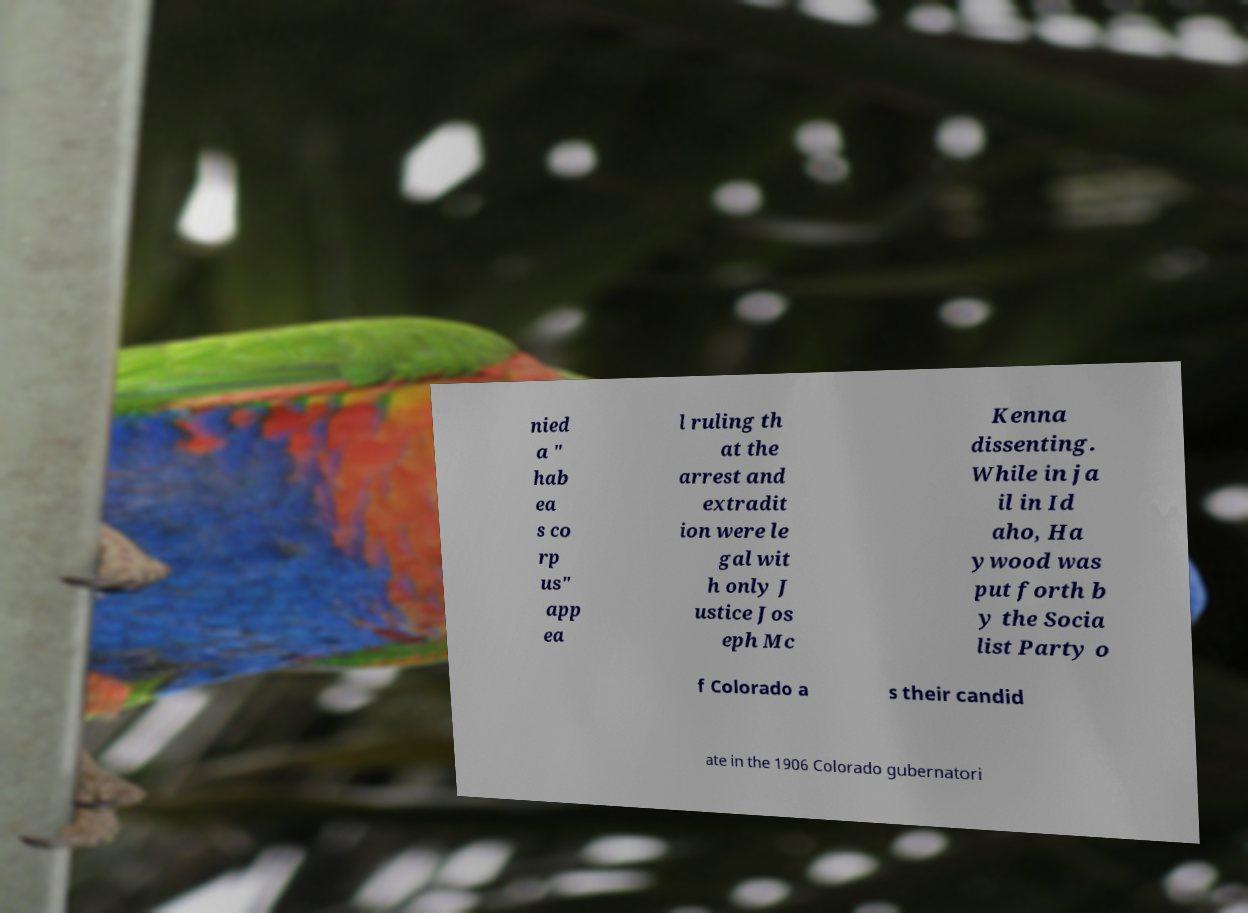Can you accurately transcribe the text from the provided image for me? nied a " hab ea s co rp us" app ea l ruling th at the arrest and extradit ion were le gal wit h only J ustice Jos eph Mc Kenna dissenting. While in ja il in Id aho, Ha ywood was put forth b y the Socia list Party o f Colorado a s their candid ate in the 1906 Colorado gubernatori 